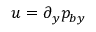<formula> <loc_0><loc_0><loc_500><loc_500>u = \partial _ { y } p _ { b y }</formula> 